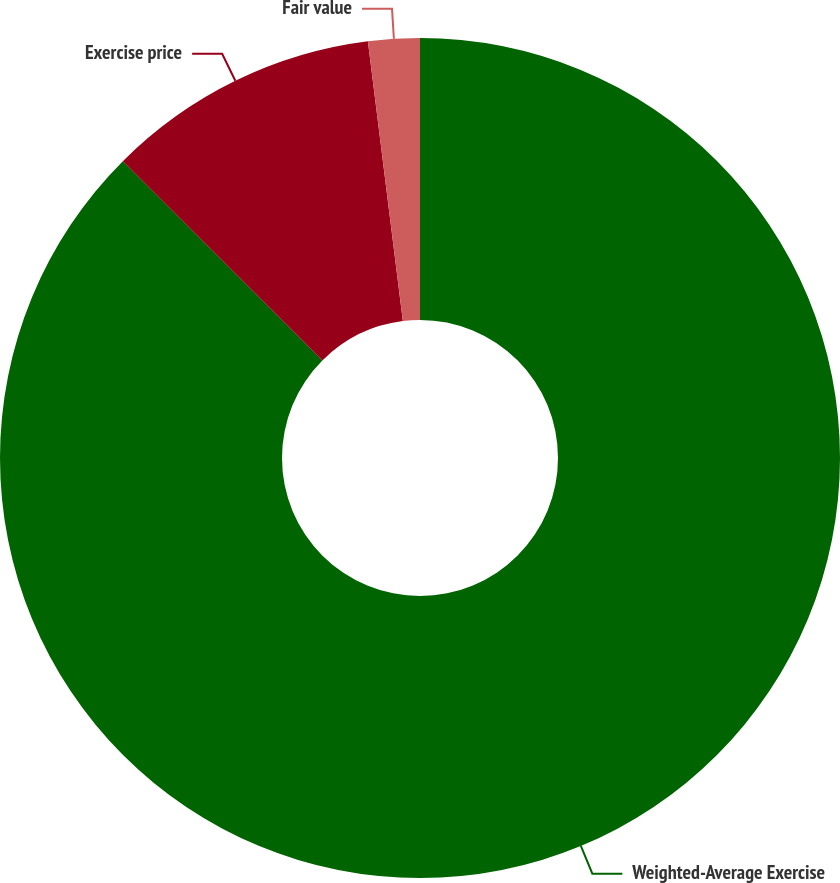Convert chart to OTSL. <chart><loc_0><loc_0><loc_500><loc_500><pie_chart><fcel>Weighted-Average Exercise<fcel>Exercise price<fcel>Fair value<nl><fcel>87.48%<fcel>10.53%<fcel>1.98%<nl></chart> 